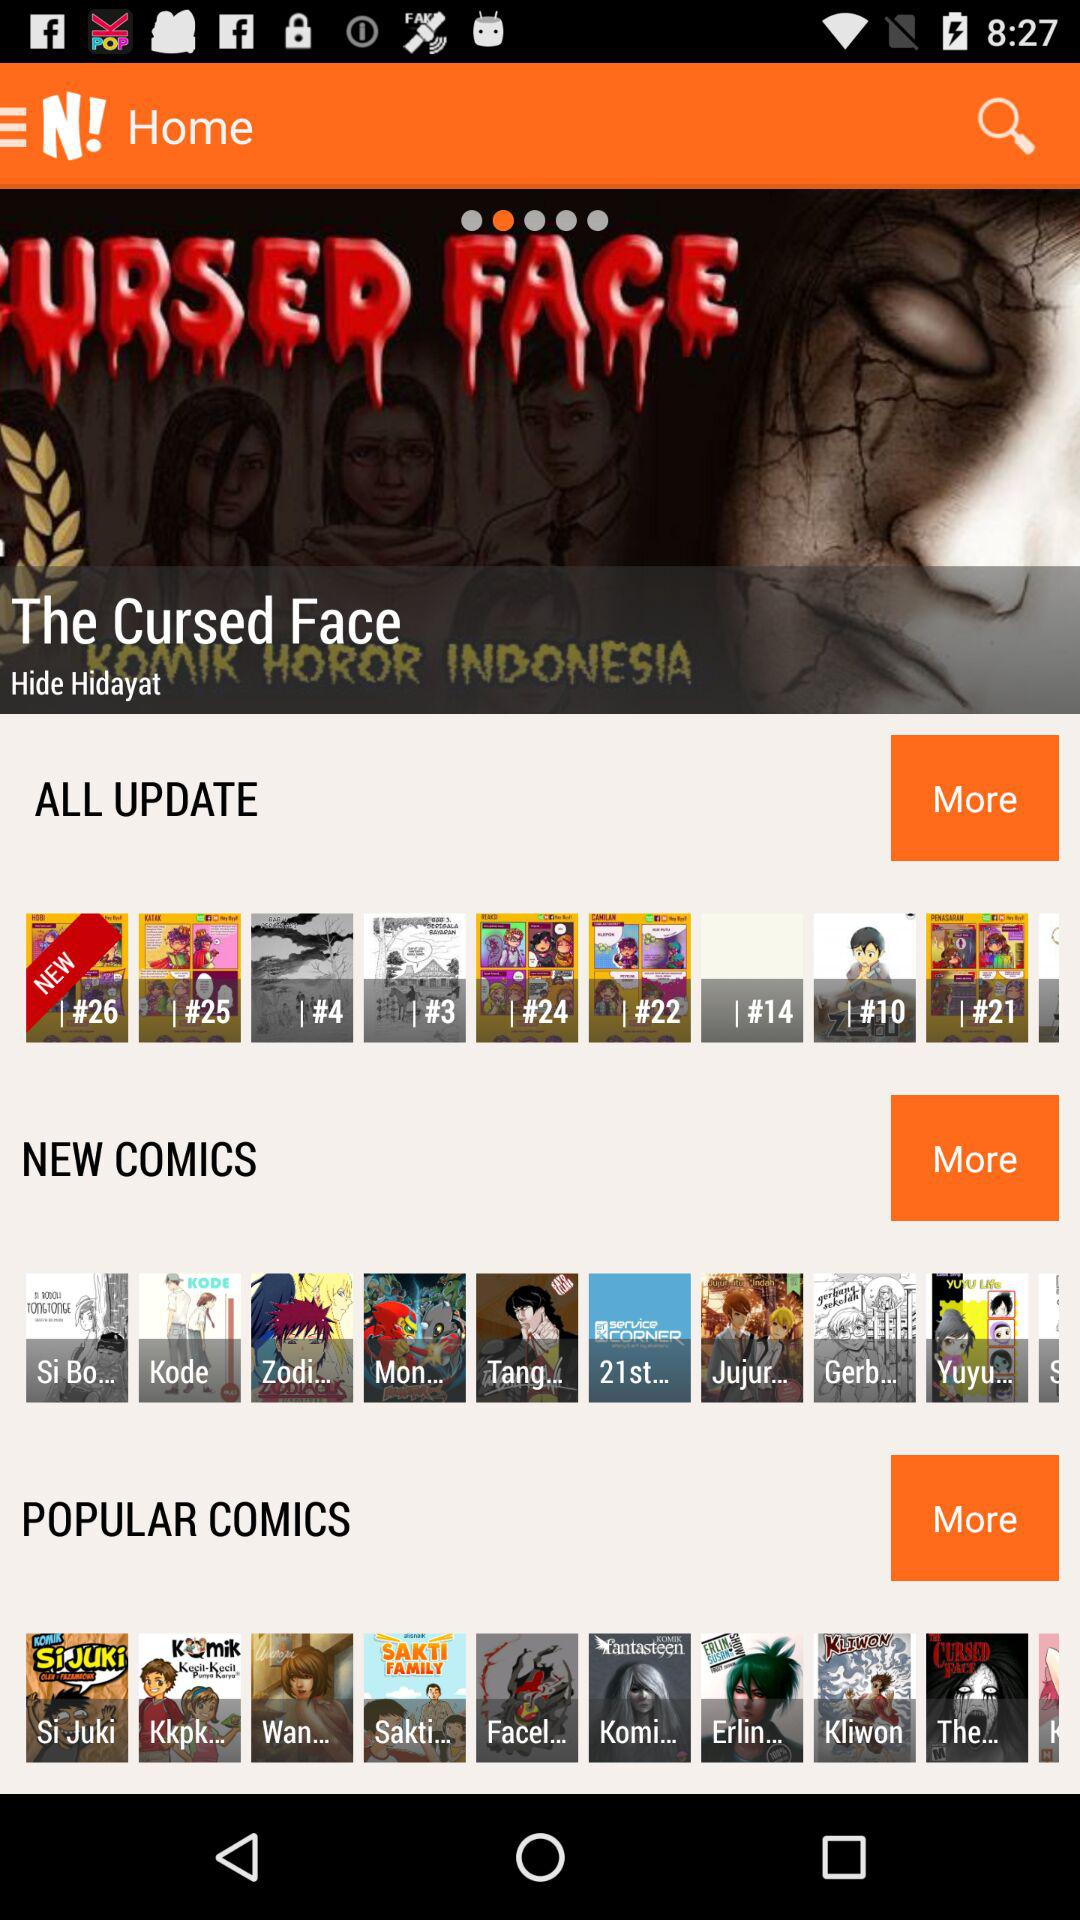What are the popular comics? The popular comics are "Si Juki", "Kkpk...", "Wan...", "Sakti...", "Facel...", "Komi...", "Erlin...", "Kliwon" and "The...". 